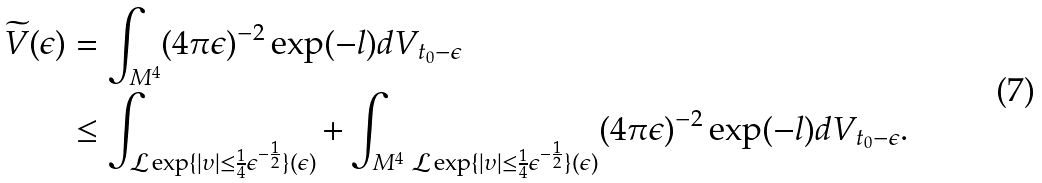Convert formula to latex. <formula><loc_0><loc_0><loc_500><loc_500>\widetilde { V } ( \epsilon ) & = \int _ { M ^ { 4 } } ( 4 \pi \epsilon ) ^ { - 2 } \exp ( - l ) d V _ { t _ { 0 } - \epsilon } \\ & \leq \int _ { \mathcal { L } \exp \{ | \upsilon | \leq \frac { 1 } { 4 } \epsilon ^ { - \frac { 1 } { 2 } } \} ( \epsilon ) } + \int _ { M ^ { 4 } \ \mathcal { L } \exp \{ | \upsilon | \leq \frac { 1 } { 4 } \epsilon ^ { - \frac { 1 } { 2 } } \} ( \epsilon ) } ( 4 \pi \epsilon ) ^ { - 2 } \exp ( - l ) d V _ { t _ { 0 } - \epsilon } .</formula> 